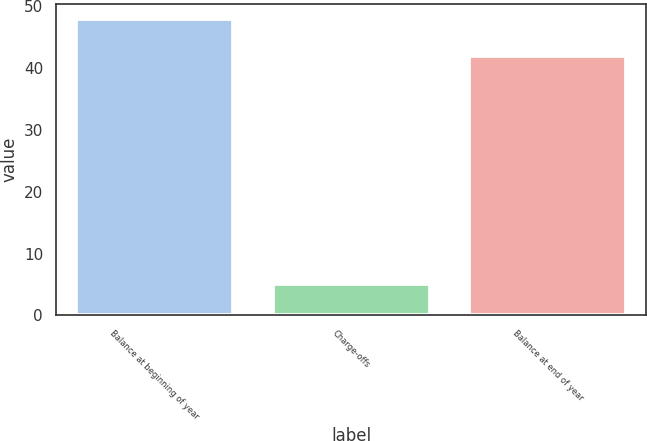<chart> <loc_0><loc_0><loc_500><loc_500><bar_chart><fcel>Balance at beginning of year<fcel>Charge-offs<fcel>Balance at end of year<nl><fcel>48<fcel>5<fcel>42<nl></chart> 